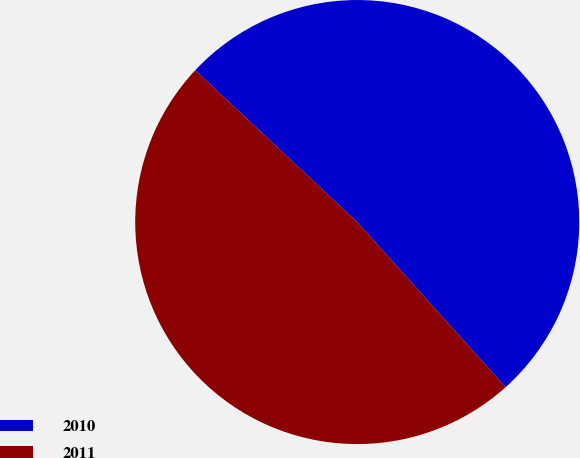Convert chart. <chart><loc_0><loc_0><loc_500><loc_500><pie_chart><fcel>2010<fcel>2011<nl><fcel>51.37%<fcel>48.63%<nl></chart> 